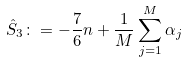<formula> <loc_0><loc_0><loc_500><loc_500>\hat { S } _ { 3 } \colon = - \frac { 7 } { 6 } n + \frac { 1 } { M } \sum _ { j = 1 } ^ { M } \alpha _ { j }</formula> 